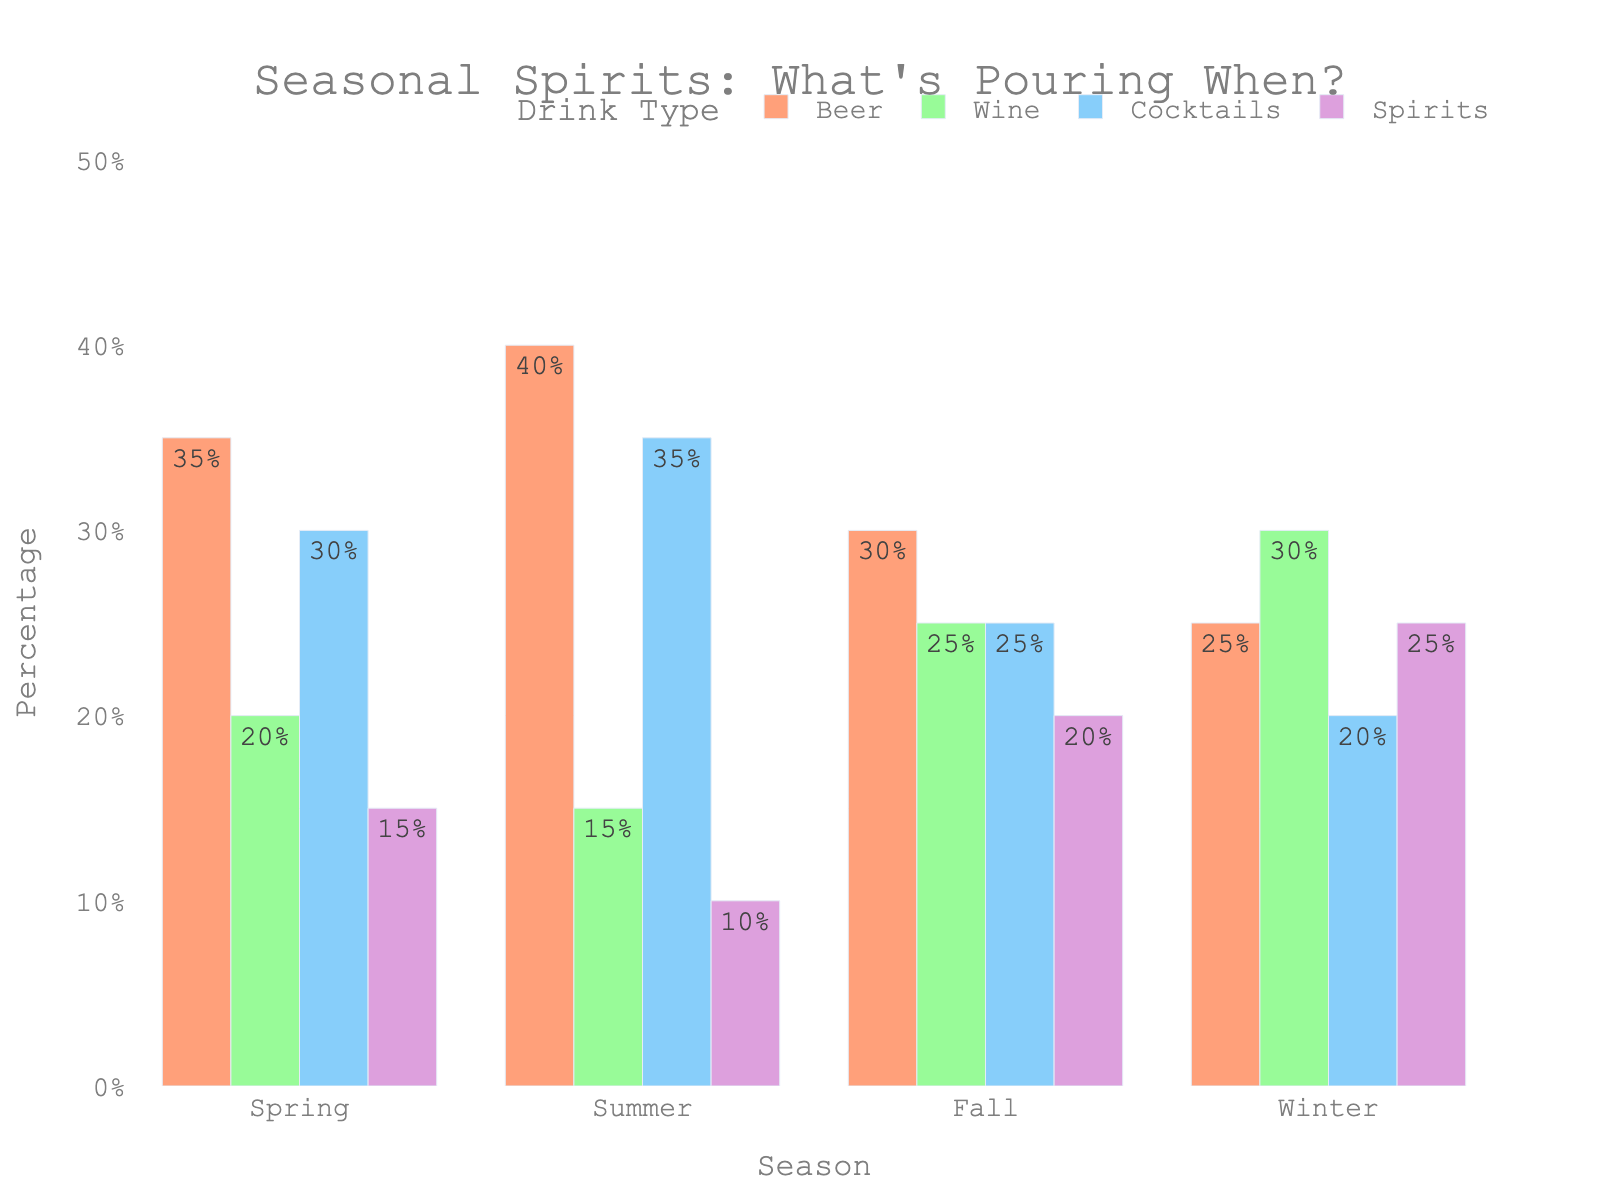What's the most popular drink type in summer? Looking at the summer bars, the tallest one represents Beer with 40%, making it the most popular drink type in summer.
Answer: Beer Is wine consumption higher in winter or fall? The bar representing Wine in winter is higher at 30%, compared to the fall bar at 25%. Thus, wine consumption is higher in winter.
Answer: Winter Which season has the lowest cocktail consumption? The bars for Cocktails show the lowest value during winter at 20%. Hence, the lowest cocktail consumption is in winter.
Answer: Winter What is the total percentage of beverages consumed in spring? Adding up the percentages for spring: Beer (35%) + Wine (20%) + Cocktails (30%) + Spirits (15%) = 100%.
Answer: 100% Between summer and winter, which season sees a higher spirits consumption, and by how much? Comparing the bars for Spirits, winter shows 25%, and summer shows 10%. The difference is 25% - 10% = 15%, with winter having higher spirits consumption.
Answer: Winter by 15% How do beer and cocktail preferences in fall compare? In fall, Beer has a 30% consumption whereas Cocktails have 25%, so beer is preferred more than cocktails in fall.
Answer: Beer is preferred more What is the difference in beer consumption between spring and winter? Spring shows a 35% beer consumption, while winter shows 25%. The difference is 35% - 25% = 10%.
Answer: 10% On average, what percentage of patrons consumed Wine across all seasons? Summing Wine values: Spring (20%) + Summer (15%) + Fall (25%) + Winter (30%) = 90%. Dividing by the 4 seasons, the average is 90% / 4 = 22.5%.
Answer: 22.5% Which drink type shows the most stable consumption across all seasons, and what indicates this? Comparing the variations of the bars for each drink type visually, Cocktails show less fluctuation around 20-35%, indicating the most stable consumption.
Answer: Cocktails show the most stable consumption What is the combined percentage of Beer and Spirits consumption in summer? Adding Beer (40%) and Spirits (10%) for summer gives a total: 40% + 10% = 50%.
Answer: 50% 